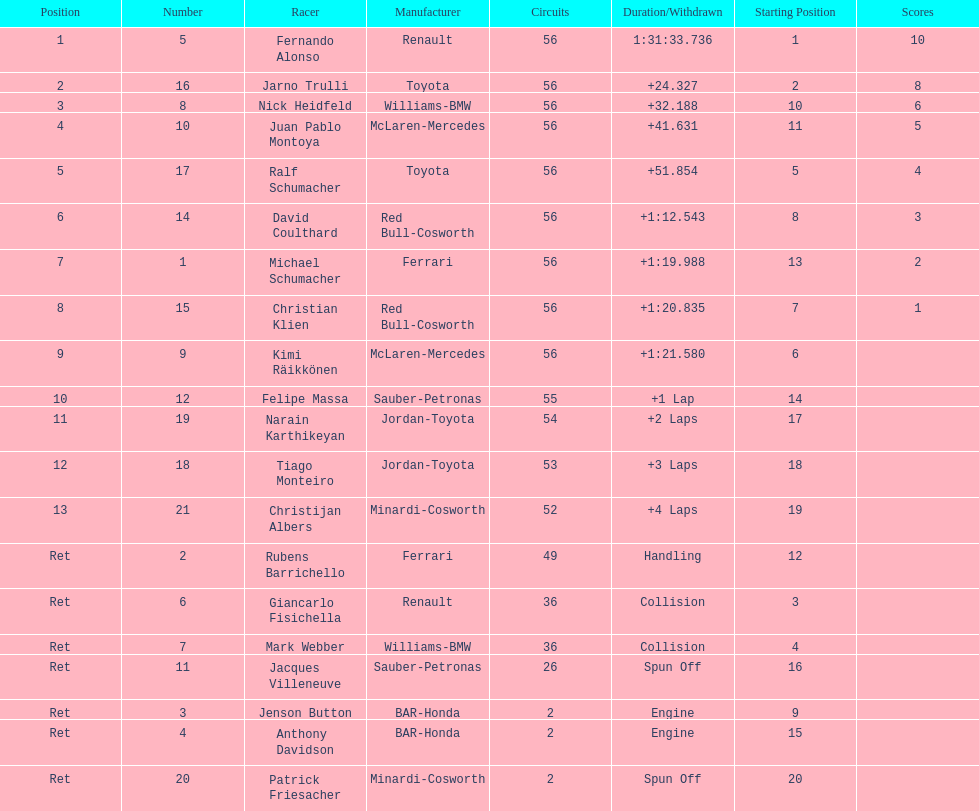How long did it take for heidfeld to finish? 1:31:65.924. 